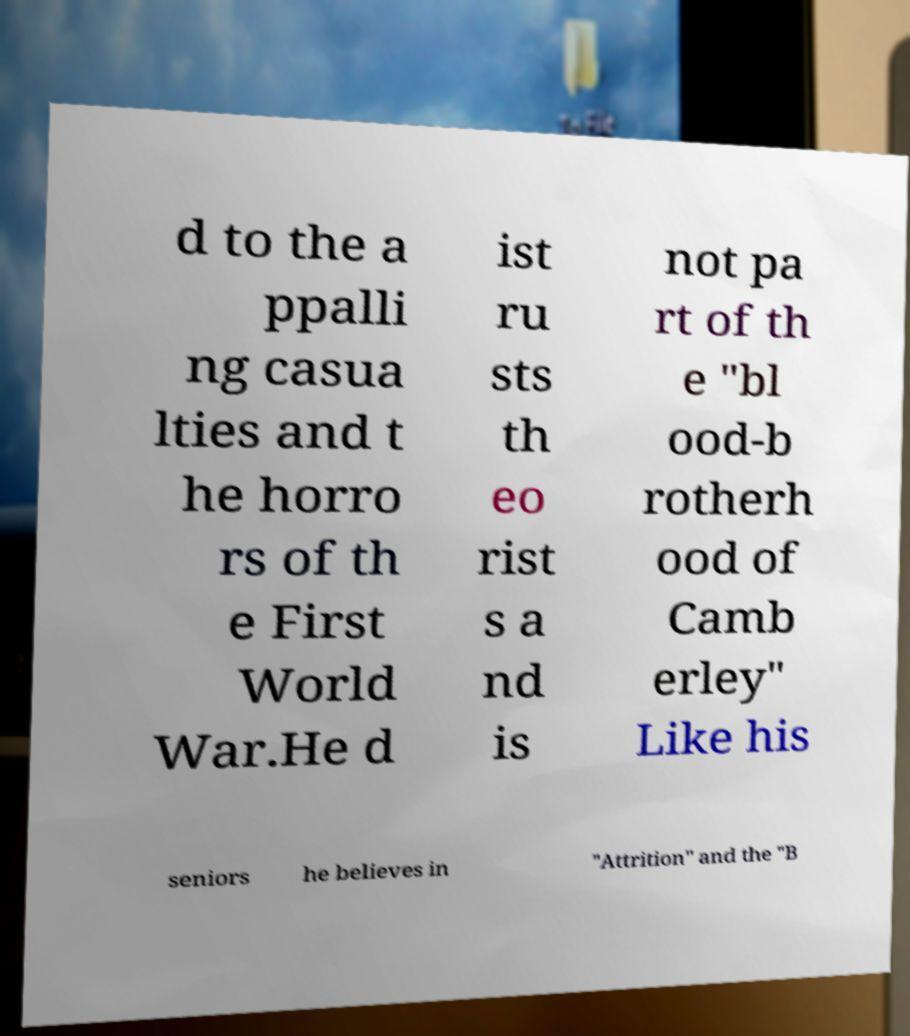Please read and relay the text visible in this image. What does it say? d to the a ppalli ng casua lties and t he horro rs of th e First World War.He d ist ru sts th eo rist s a nd is not pa rt of th e "bl ood-b rotherh ood of Camb erley" Like his seniors he believes in "Attrition" and the "B 